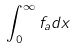<formula> <loc_0><loc_0><loc_500><loc_500>\int _ { 0 } ^ { \infty } f _ { a } d x</formula> 